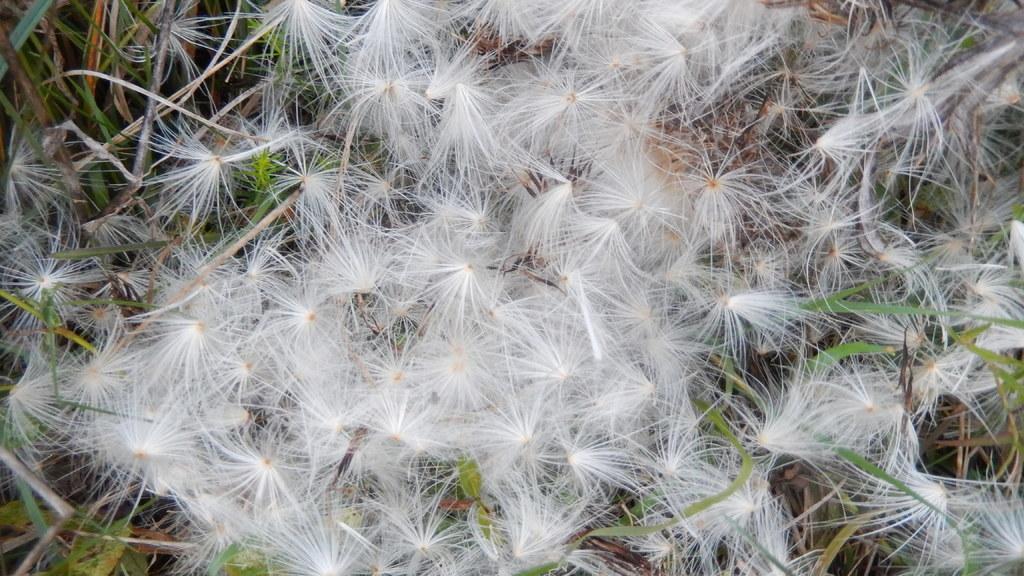Describe this image in one or two sentences. In this picture I can see there is a dandelion and it is in white color. I can find there is some grass and twigs on the floor. 